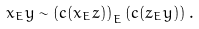Convert formula to latex. <formula><loc_0><loc_0><loc_500><loc_500>x _ { E } y \sim \left ( c ( x _ { E } z ) \right ) _ { E } \left ( c ( z _ { E } y ) \right ) .</formula> 